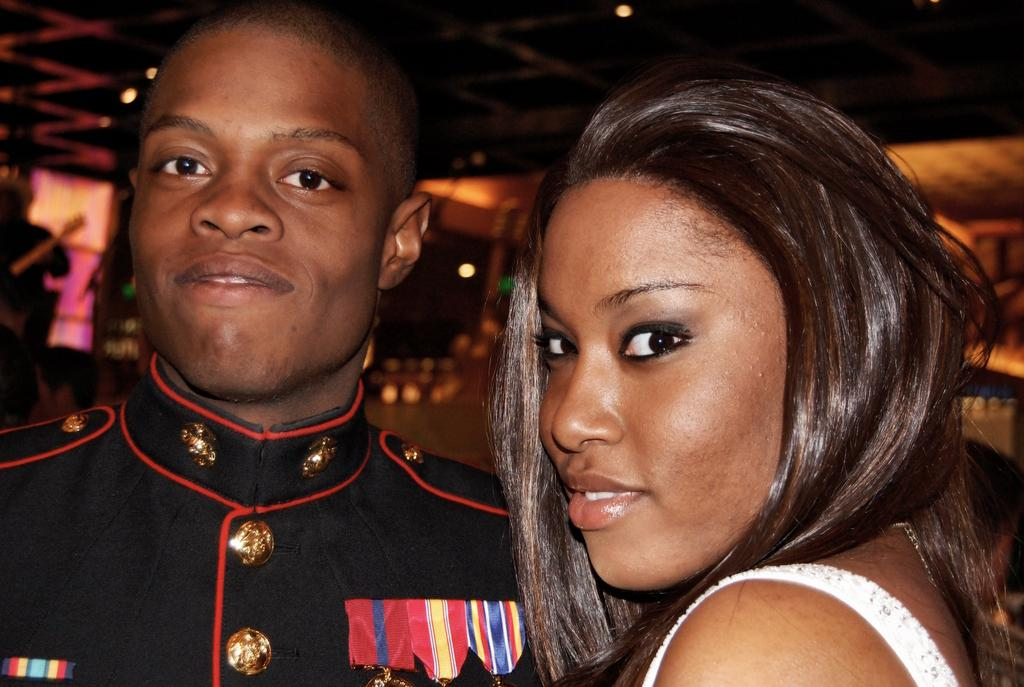How many people are in the image? There are two persons in the image. What are the two persons doing in the image? The two persons are standing. Where are the two persons located in the image? The two persons are in the center of the image. What type of shoe can be seen sinking in the quicksand in the image? There is no shoe or quicksand present in the image; it features two standing persons in the center. 